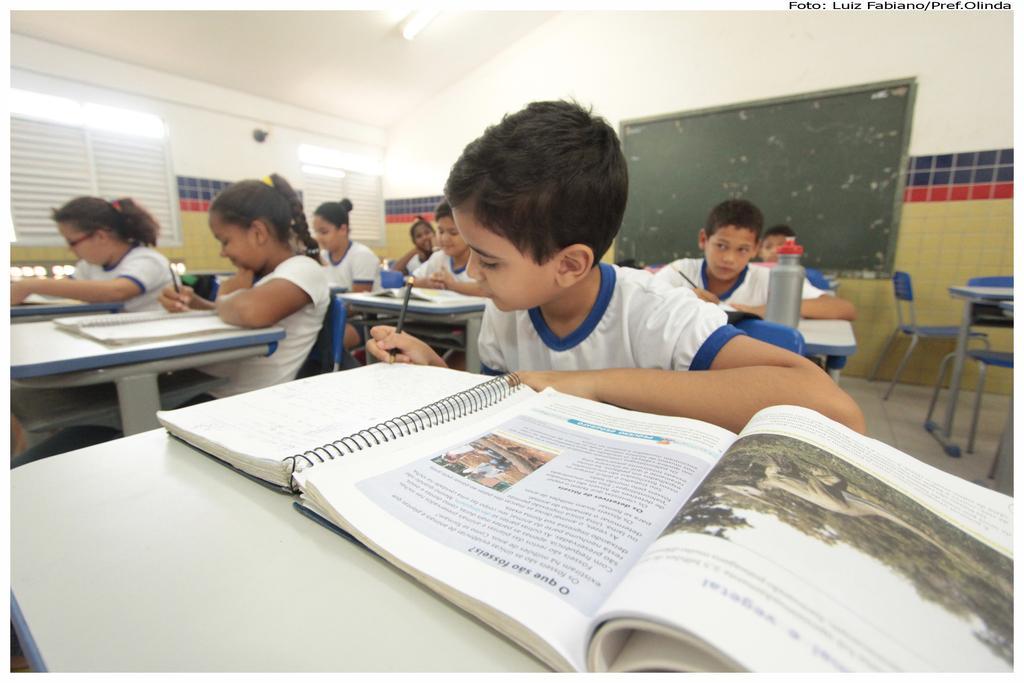Please provide a concise description of this image. In the center of the image we can see one kid is holding some object and he is writing something on the book. In front of him, we can see one table. On the table, we can see the books. In the background there is a wall, board, window blinds, lights, tables, chairs, one bottle, books, few kids are sitting, few kids are holding some objects and a few other objects. 